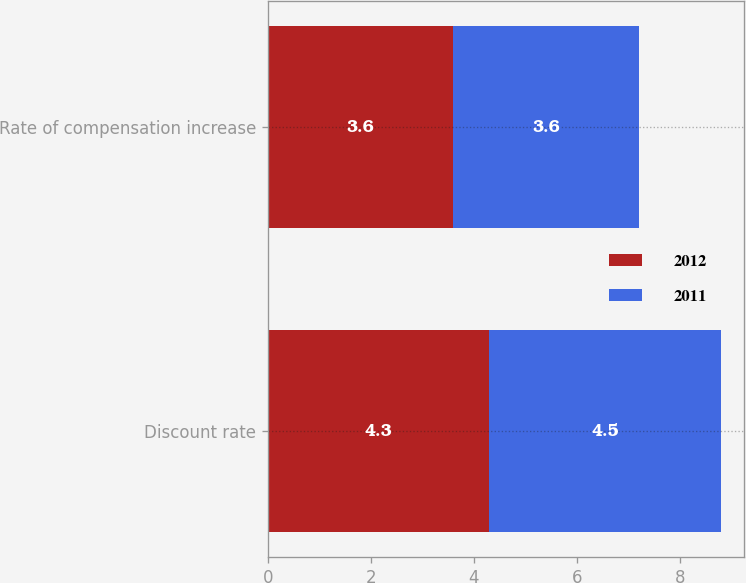<chart> <loc_0><loc_0><loc_500><loc_500><stacked_bar_chart><ecel><fcel>Discount rate<fcel>Rate of compensation increase<nl><fcel>2012<fcel>4.3<fcel>3.6<nl><fcel>2011<fcel>4.5<fcel>3.6<nl></chart> 